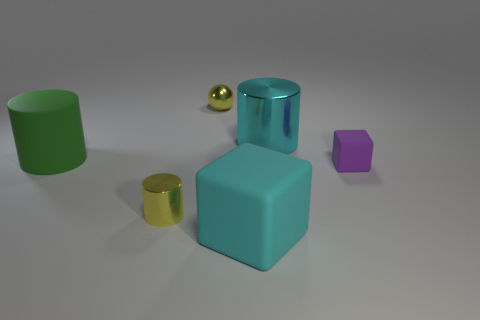There is a matte cube that is the same color as the big metallic cylinder; what size is it?
Your answer should be very brief. Large. Does the cube that is in front of the purple block have the same color as the big shiny cylinder?
Your answer should be compact. Yes. Is there a large object that has the same color as the large rubber cube?
Ensure brevity in your answer.  Yes. Do the matte cube that is to the left of the large cyan metal object and the large cylinder right of the small yellow cylinder have the same color?
Ensure brevity in your answer.  Yes. The green cylinder that is made of the same material as the big cyan block is what size?
Your response must be concise. Large. What number of tiny things are green objects or red spheres?
Give a very brief answer. 0. There is a metal thing in front of the block behind the shiny thing on the left side of the small shiny ball; how big is it?
Offer a terse response. Small. What number of matte objects are the same size as the green cylinder?
Give a very brief answer. 1. What number of objects are either green objects or cyan things behind the cyan rubber block?
Provide a short and direct response. 2. The big green matte thing is what shape?
Offer a terse response. Cylinder. 